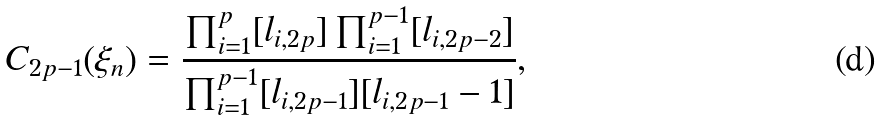Convert formula to latex. <formula><loc_0><loc_0><loc_500><loc_500>C _ { 2 p - 1 } ( \xi _ { n } ) = \frac { \prod _ { i = 1 } ^ { p } [ l _ { i , 2 p } ] \prod _ { i = 1 } ^ { p - 1 } [ l _ { i , 2 p - 2 } ] } { \prod _ { i = 1 } ^ { p - 1 } [ l _ { i , 2 p - 1 } ] [ l _ { i , 2 p - 1 } - 1 ] } ,</formula> 